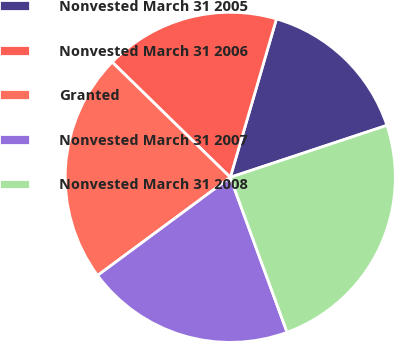<chart> <loc_0><loc_0><loc_500><loc_500><pie_chart><fcel>Nonvested March 31 2005<fcel>Nonvested March 31 2006<fcel>Granted<fcel>Nonvested March 31 2007<fcel>Nonvested March 31 2008<nl><fcel>15.39%<fcel>17.21%<fcel>22.44%<fcel>20.46%<fcel>24.51%<nl></chart> 